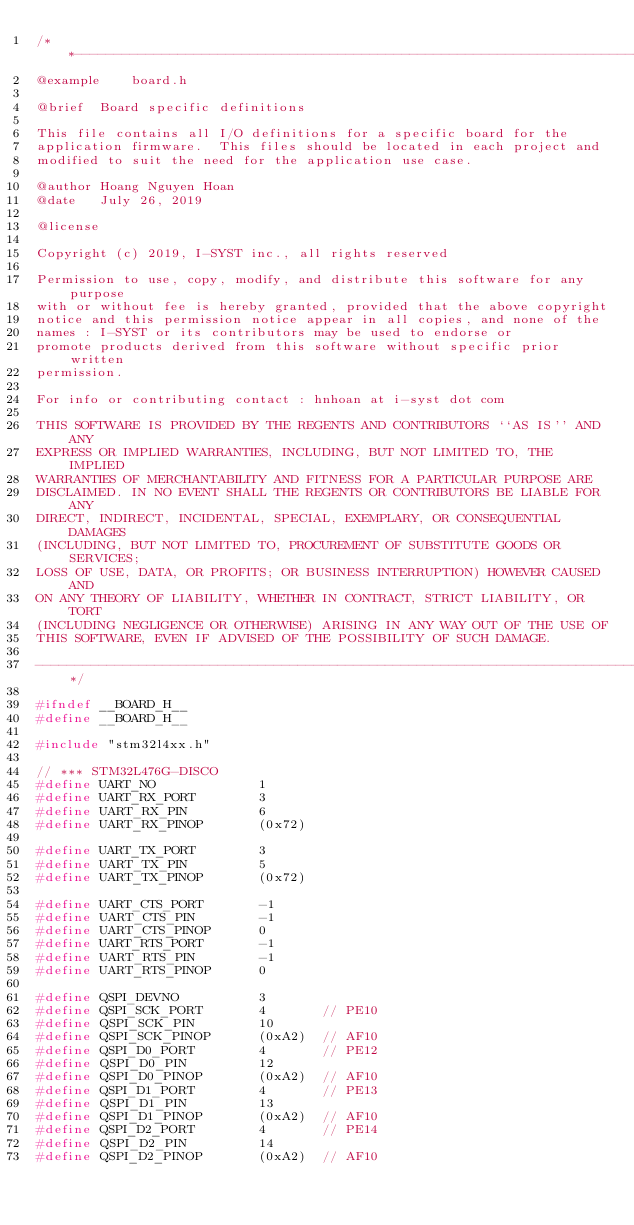<code> <loc_0><loc_0><loc_500><loc_500><_C_>/**-------------------------------------------------------------------------
@example	board.h

@brief	Board specific definitions

This file contains all I/O definitions for a specific board for the
application firmware.  This files should be located in each project and
modified to suit the need for the application use case.

@author	Hoang Nguyen Hoan
@date	July 26, 2019

@license

Copyright (c) 2019, I-SYST inc., all rights reserved

Permission to use, copy, modify, and distribute this software for any purpose
with or without fee is hereby granted, provided that the above copyright
notice and this permission notice appear in all copies, and none of the
names : I-SYST or its contributors may be used to endorse or
promote products derived from this software without specific prior written
permission.

For info or contributing contact : hnhoan at i-syst dot com

THIS SOFTWARE IS PROVIDED BY THE REGENTS AND CONTRIBUTORS ``AS IS'' AND ANY
EXPRESS OR IMPLIED WARRANTIES, INCLUDING, BUT NOT LIMITED TO, THE IMPLIED
WARRANTIES OF MERCHANTABILITY AND FITNESS FOR A PARTICULAR PURPOSE ARE
DISCLAIMED. IN NO EVENT SHALL THE REGENTS OR CONTRIBUTORS BE LIABLE FOR ANY
DIRECT, INDIRECT, INCIDENTAL, SPECIAL, EXEMPLARY, OR CONSEQUENTIAL DAMAGES
(INCLUDING, BUT NOT LIMITED TO, PROCUREMENT OF SUBSTITUTE GOODS OR SERVICES;
LOSS OF USE, DATA, OR PROFITS; OR BUSINESS INTERRUPTION) HOWEVER CAUSED AND
ON ANY THEORY OF LIABILITY, WHETHER IN CONTRACT, STRICT LIABILITY, OR TORT
(INCLUDING NEGLIGENCE OR OTHERWISE) ARISING IN ANY WAY OUT OF THE USE OF
THIS SOFTWARE, EVEN IF ADVISED OF THE POSSIBILITY OF SUCH DAMAGE.

----------------------------------------------------------------------------*/

#ifndef __BOARD_H__
#define __BOARD_H__

#include "stm32l4xx.h"

// *** STM32L476G-DISCO
#define UART_NO				1
#define UART_RX_PORT		3
#define UART_RX_PIN			6
#define UART_RX_PINOP		(0x72)

#define UART_TX_PORT		3
#define UART_TX_PIN			5
#define UART_TX_PINOP		(0x72)

#define UART_CTS_PORT		-1
#define UART_CTS_PIN		-1
#define UART_CTS_PINOP		0
#define UART_RTS_PORT		-1
#define UART_RTS_PIN		-1
#define UART_RTS_PINOP		0

#define QSPI_DEVNO			3
#define QSPI_SCK_PORT       4		// PE10
#define QSPI_SCK_PIN        10
#define QSPI_SCK_PINOP      (0xA2)	// AF10
#define QSPI_D0_PORT		4		// PE12
#define QSPI_D0_PIN        	12
#define QSPI_D0_PINOP      	(0xA2)	// AF10
#define QSPI_D1_PORT		4		// PE13
#define QSPI_D1_PIN        	13
#define QSPI_D1_PINOP      	(0xA2)	// AF10
#define QSPI_D2_PORT		4		// PE14
#define QSPI_D2_PIN        	14
#define QSPI_D2_PINOP      	(0xA2)	// AF10</code> 